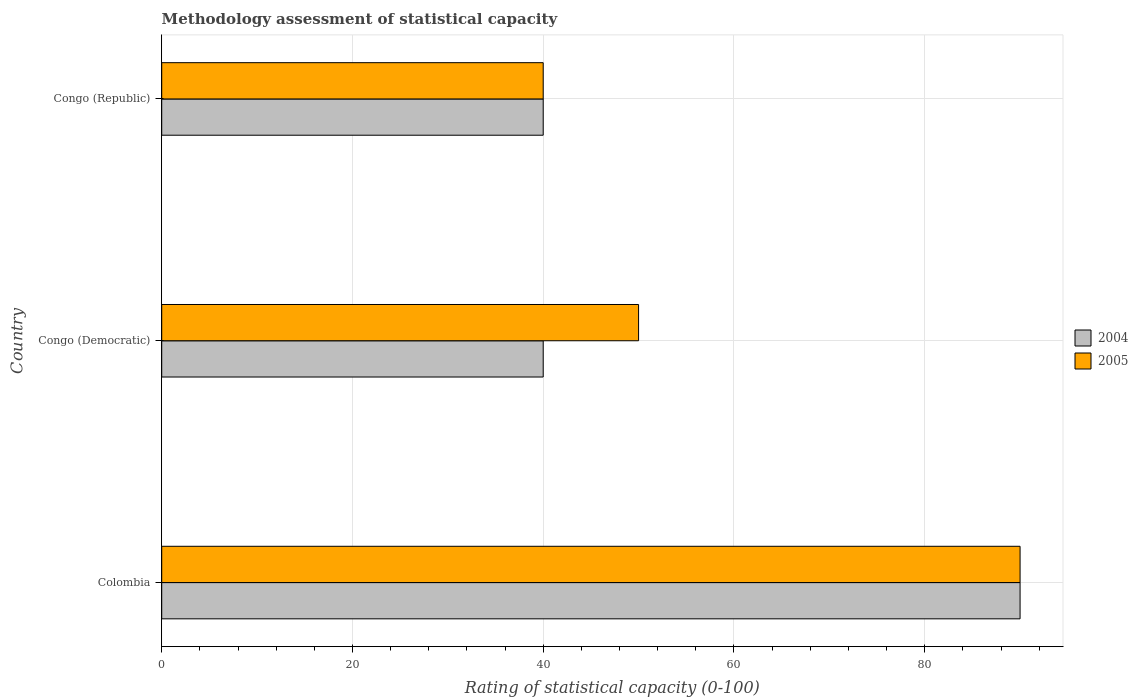How many groups of bars are there?
Your answer should be compact. 3. Are the number of bars per tick equal to the number of legend labels?
Ensure brevity in your answer.  Yes. How many bars are there on the 3rd tick from the top?
Your response must be concise. 2. How many bars are there on the 1st tick from the bottom?
Your response must be concise. 2. In how many cases, is the number of bars for a given country not equal to the number of legend labels?
Ensure brevity in your answer.  0. What is the rating of statistical capacity in 2004 in Congo (Republic)?
Make the answer very short. 40. Across all countries, what is the maximum rating of statistical capacity in 2004?
Keep it short and to the point. 90. Across all countries, what is the minimum rating of statistical capacity in 2005?
Give a very brief answer. 40. In which country was the rating of statistical capacity in 2004 minimum?
Your answer should be very brief. Congo (Democratic). What is the total rating of statistical capacity in 2004 in the graph?
Offer a terse response. 170. What is the ratio of the rating of statistical capacity in 2004 in Colombia to that in Congo (Republic)?
Offer a very short reply. 2.25. Is the rating of statistical capacity in 2004 in Colombia less than that in Congo (Republic)?
Your answer should be very brief. No. Is the difference between the rating of statistical capacity in 2005 in Colombia and Congo (Democratic) greater than the difference between the rating of statistical capacity in 2004 in Colombia and Congo (Democratic)?
Offer a very short reply. No. Is the sum of the rating of statistical capacity in 2005 in Colombia and Congo (Democratic) greater than the maximum rating of statistical capacity in 2004 across all countries?
Offer a very short reply. Yes. What does the 2nd bar from the top in Congo (Democratic) represents?
Provide a succinct answer. 2004. What does the 1st bar from the bottom in Congo (Democratic) represents?
Provide a short and direct response. 2004. What is the difference between two consecutive major ticks on the X-axis?
Your response must be concise. 20. Are the values on the major ticks of X-axis written in scientific E-notation?
Your response must be concise. No. Does the graph contain any zero values?
Provide a short and direct response. No. Does the graph contain grids?
Make the answer very short. Yes. How are the legend labels stacked?
Your response must be concise. Vertical. What is the title of the graph?
Your answer should be very brief. Methodology assessment of statistical capacity. What is the label or title of the X-axis?
Provide a succinct answer. Rating of statistical capacity (0-100). What is the Rating of statistical capacity (0-100) in 2004 in Colombia?
Your answer should be very brief. 90. What is the Rating of statistical capacity (0-100) of 2005 in Colombia?
Give a very brief answer. 90. What is the Rating of statistical capacity (0-100) of 2004 in Congo (Republic)?
Your answer should be compact. 40. What is the Rating of statistical capacity (0-100) of 2005 in Congo (Republic)?
Offer a terse response. 40. Across all countries, what is the maximum Rating of statistical capacity (0-100) in 2004?
Your answer should be compact. 90. Across all countries, what is the minimum Rating of statistical capacity (0-100) in 2005?
Offer a very short reply. 40. What is the total Rating of statistical capacity (0-100) of 2004 in the graph?
Your answer should be very brief. 170. What is the total Rating of statistical capacity (0-100) in 2005 in the graph?
Your response must be concise. 180. What is the difference between the Rating of statistical capacity (0-100) of 2004 in Colombia and that in Congo (Democratic)?
Offer a terse response. 50. What is the difference between the Rating of statistical capacity (0-100) in 2004 in Congo (Democratic) and that in Congo (Republic)?
Offer a very short reply. 0. What is the difference between the Rating of statistical capacity (0-100) in 2004 in Colombia and the Rating of statistical capacity (0-100) in 2005 in Congo (Democratic)?
Make the answer very short. 40. What is the difference between the Rating of statistical capacity (0-100) of 2004 in Colombia and the Rating of statistical capacity (0-100) of 2005 in Congo (Republic)?
Your response must be concise. 50. What is the difference between the Rating of statistical capacity (0-100) in 2004 in Congo (Democratic) and the Rating of statistical capacity (0-100) in 2005 in Congo (Republic)?
Make the answer very short. 0. What is the average Rating of statistical capacity (0-100) of 2004 per country?
Your response must be concise. 56.67. What is the average Rating of statistical capacity (0-100) in 2005 per country?
Keep it short and to the point. 60. What is the difference between the Rating of statistical capacity (0-100) in 2004 and Rating of statistical capacity (0-100) in 2005 in Congo (Republic)?
Offer a terse response. 0. What is the ratio of the Rating of statistical capacity (0-100) of 2004 in Colombia to that in Congo (Democratic)?
Make the answer very short. 2.25. What is the ratio of the Rating of statistical capacity (0-100) of 2005 in Colombia to that in Congo (Democratic)?
Offer a very short reply. 1.8. What is the ratio of the Rating of statistical capacity (0-100) of 2004 in Colombia to that in Congo (Republic)?
Keep it short and to the point. 2.25. What is the ratio of the Rating of statistical capacity (0-100) in 2005 in Colombia to that in Congo (Republic)?
Offer a very short reply. 2.25. What is the ratio of the Rating of statistical capacity (0-100) of 2004 in Congo (Democratic) to that in Congo (Republic)?
Keep it short and to the point. 1. What is the difference between the highest and the second highest Rating of statistical capacity (0-100) of 2005?
Offer a very short reply. 40. What is the difference between the highest and the lowest Rating of statistical capacity (0-100) of 2004?
Offer a very short reply. 50. 